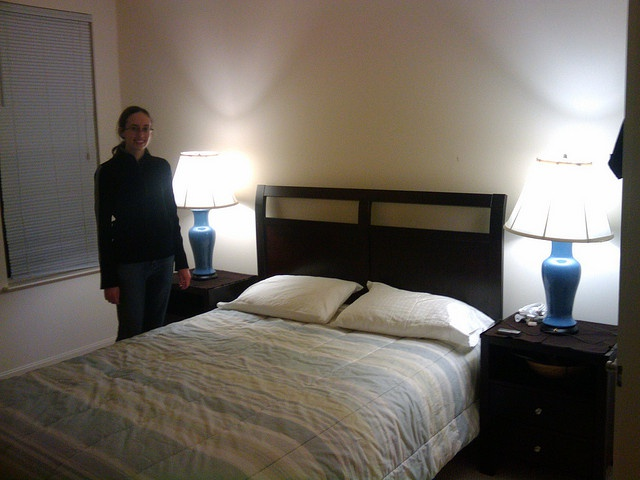Describe the objects in this image and their specific colors. I can see bed in darkgreen, black, gray, and darkgray tones and people in darkgreen, black, gray, and maroon tones in this image. 